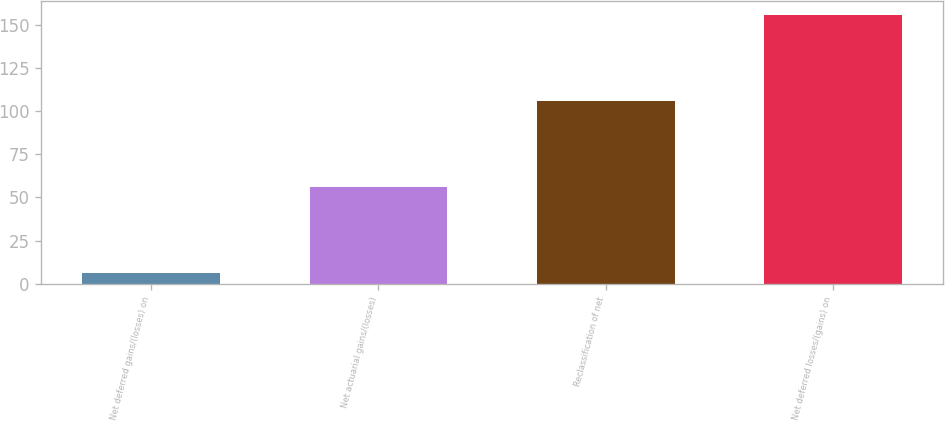Convert chart to OTSL. <chart><loc_0><loc_0><loc_500><loc_500><bar_chart><fcel>Net deferred gains/(losses) on<fcel>Net actuarial gains/(losses)<fcel>Reclassification of net<fcel>Net deferred losses/(gains) on<nl><fcel>6<fcel>56<fcel>106<fcel>156<nl></chart> 